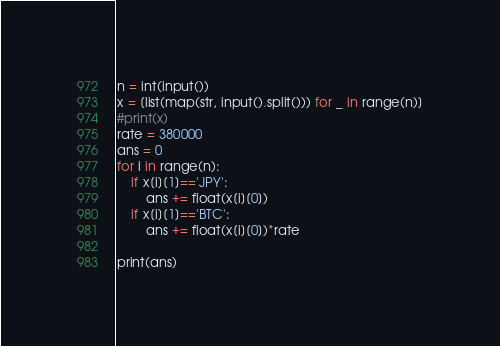Convert code to text. <code><loc_0><loc_0><loc_500><loc_500><_Python_>n = int(input())
x = [list(map(str, input().split())) for _ in range(n)]
#print(x)
rate = 380000
ans = 0
for i in range(n):
    if x[i][1]=='JPY':
        ans += float(x[i][0])
    if x[i][1]=='BTC':
        ans += float(x[i][0])*rate

print(ans)</code> 